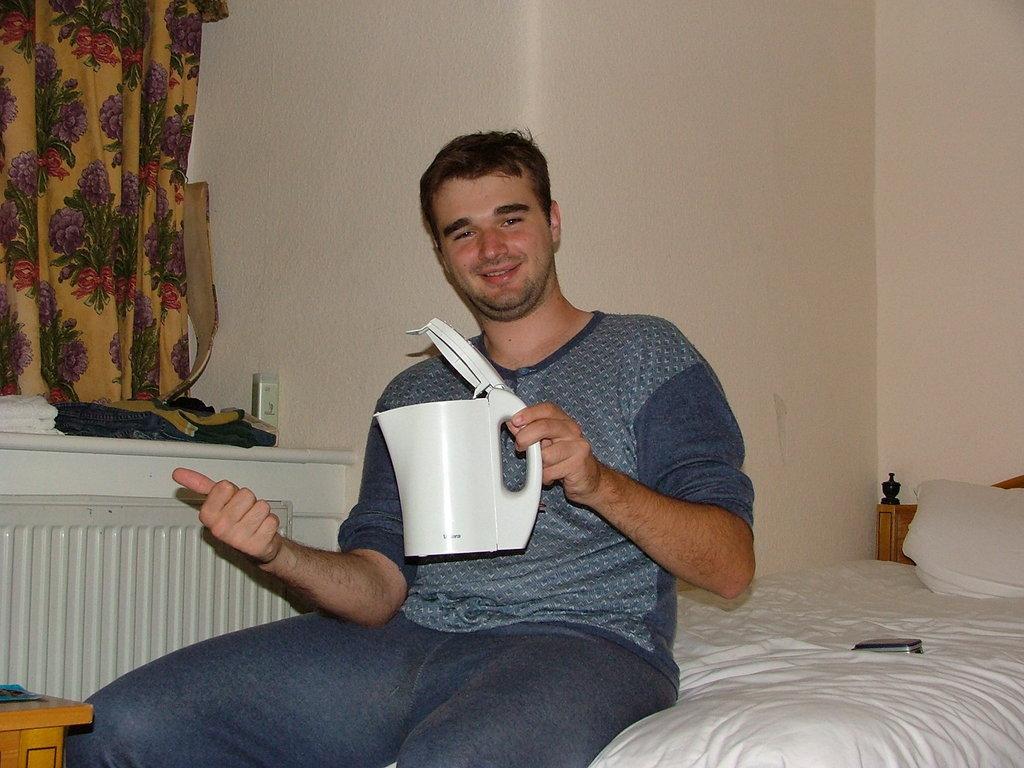How would you summarize this image in a sentence or two? A person is sitting on bed holding a flask in his hand. At the left there is a table on which there is some clothes. On it left side there is a curtain. 